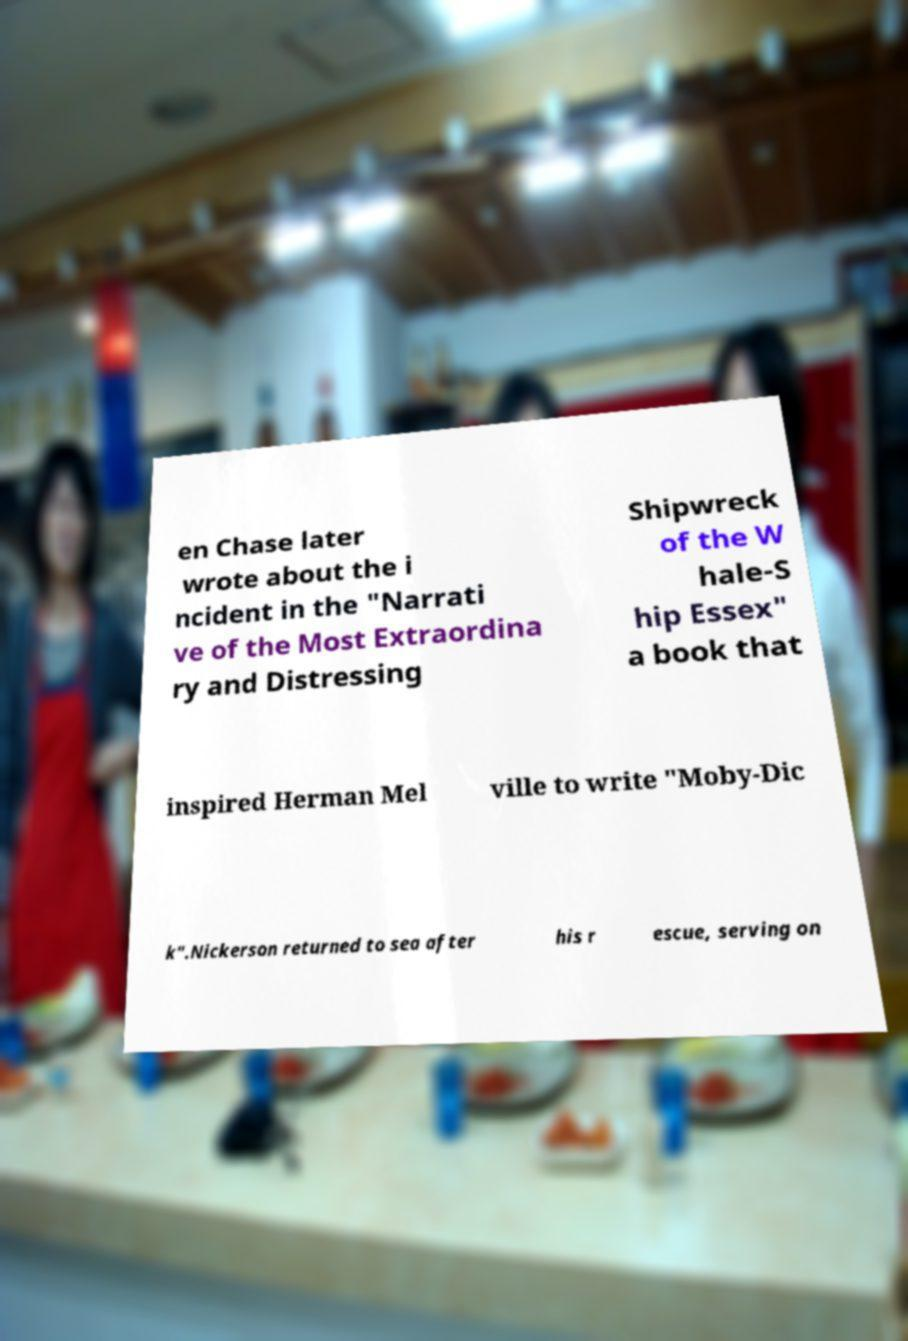For documentation purposes, I need the text within this image transcribed. Could you provide that? en Chase later wrote about the i ncident in the "Narrati ve of the Most Extraordina ry and Distressing Shipwreck of the W hale-S hip Essex" a book that inspired Herman Mel ville to write "Moby-Dic k".Nickerson returned to sea after his r escue, serving on 